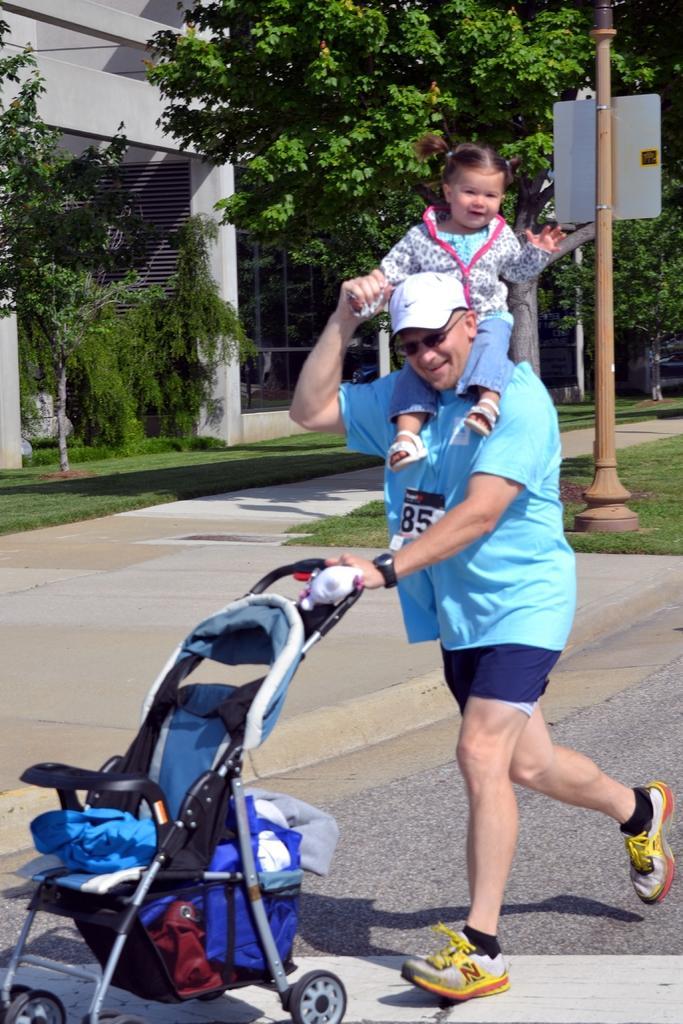Could you give a brief overview of what you see in this image? In this picture I can see there is a man standing, he is carrying the child on his shoulder and he is holding a trolley, I can see there is a walkway, there are trees, there is a building and plants. 